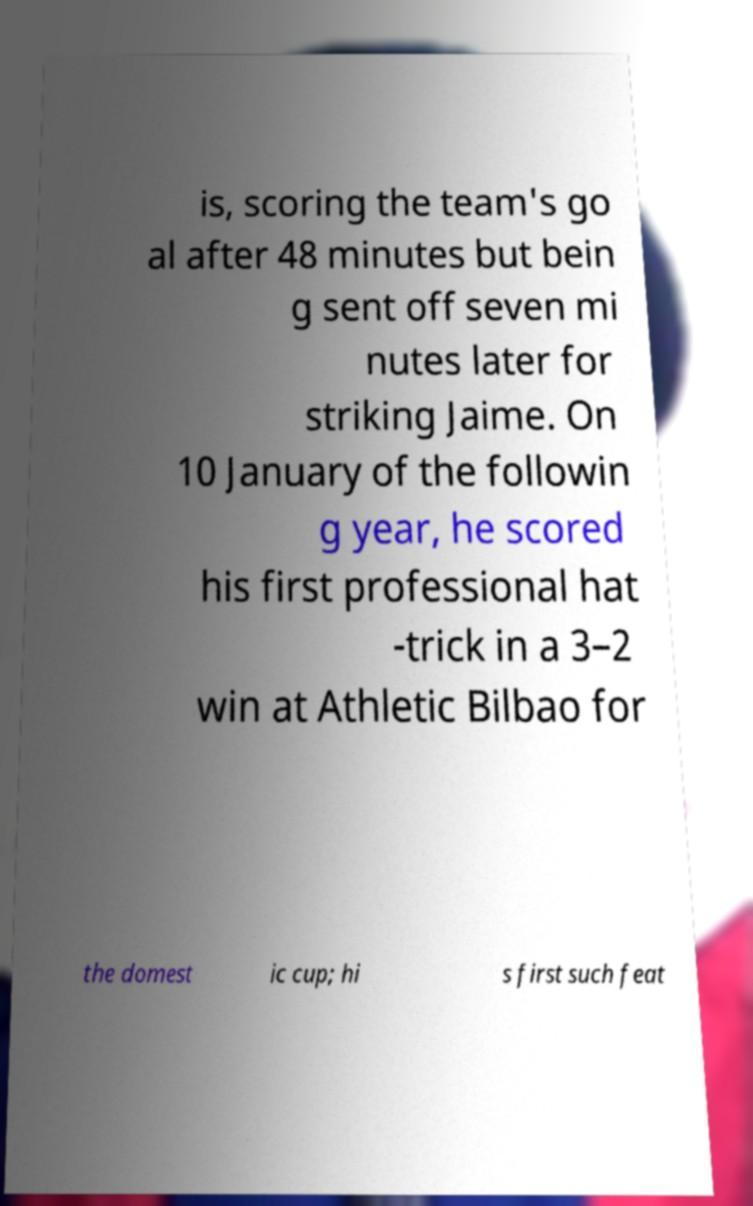Could you extract and type out the text from this image? is, scoring the team's go al after 48 minutes but bein g sent off seven mi nutes later for striking Jaime. On 10 January of the followin g year, he scored his first professional hat -trick in a 3–2 win at Athletic Bilbao for the domest ic cup; hi s first such feat 